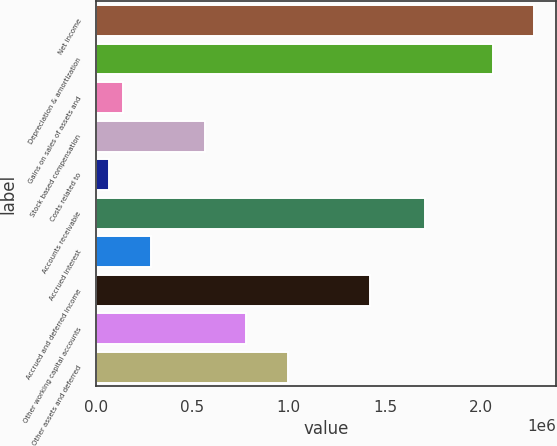Convert chart to OTSL. <chart><loc_0><loc_0><loc_500><loc_500><bar_chart><fcel>Net income<fcel>Depreciation & amortization<fcel>Gains on sales of assets and<fcel>Stock based compensation<fcel>Costs related to<fcel>Accounts receivable<fcel>Accrued interest<fcel>Accrued and deferred income<fcel>Other working capital accounts<fcel>Other assets and deferred<nl><fcel>2.27418e+06<fcel>2.06098e+06<fcel>142137<fcel>568546<fcel>71068.7<fcel>1.70564e+06<fcel>284273<fcel>1.42137e+06<fcel>781751<fcel>994956<nl></chart> 